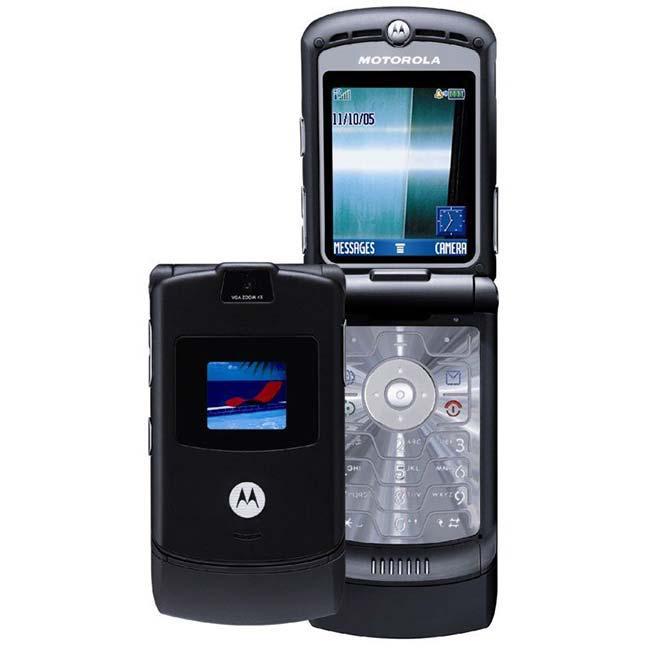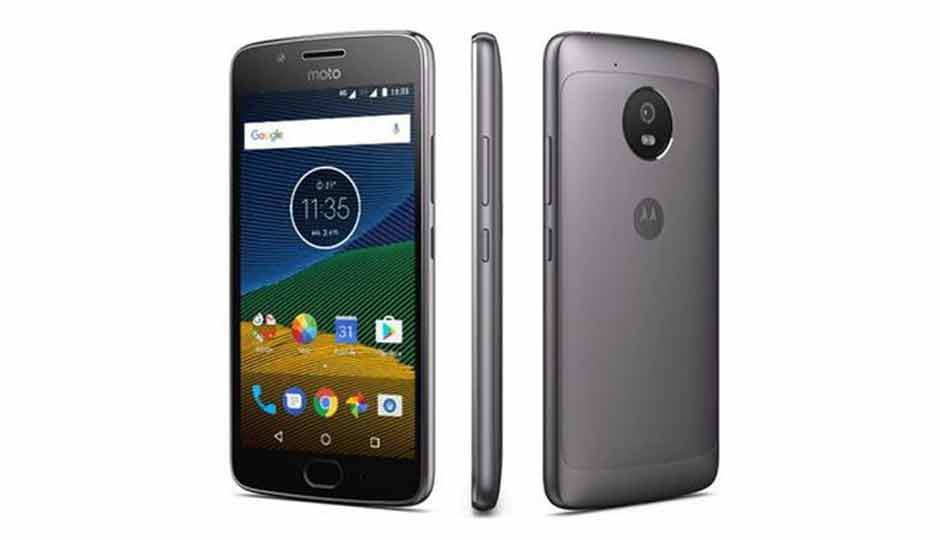The first image is the image on the left, the second image is the image on the right. For the images displayed, is the sentence "Three or fewer phones are visible." factually correct? Answer yes or no. No. The first image is the image on the left, the second image is the image on the right. Examine the images to the left and right. Is the description "At least one flip phone is visible in the right image." accurate? Answer yes or no. No. 